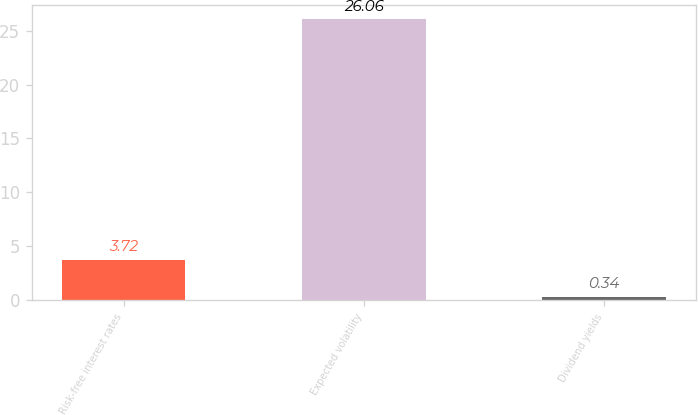<chart> <loc_0><loc_0><loc_500><loc_500><bar_chart><fcel>Risk-free interest rates<fcel>Expected volatility<fcel>Dividend yields<nl><fcel>3.72<fcel>26.06<fcel>0.34<nl></chart> 